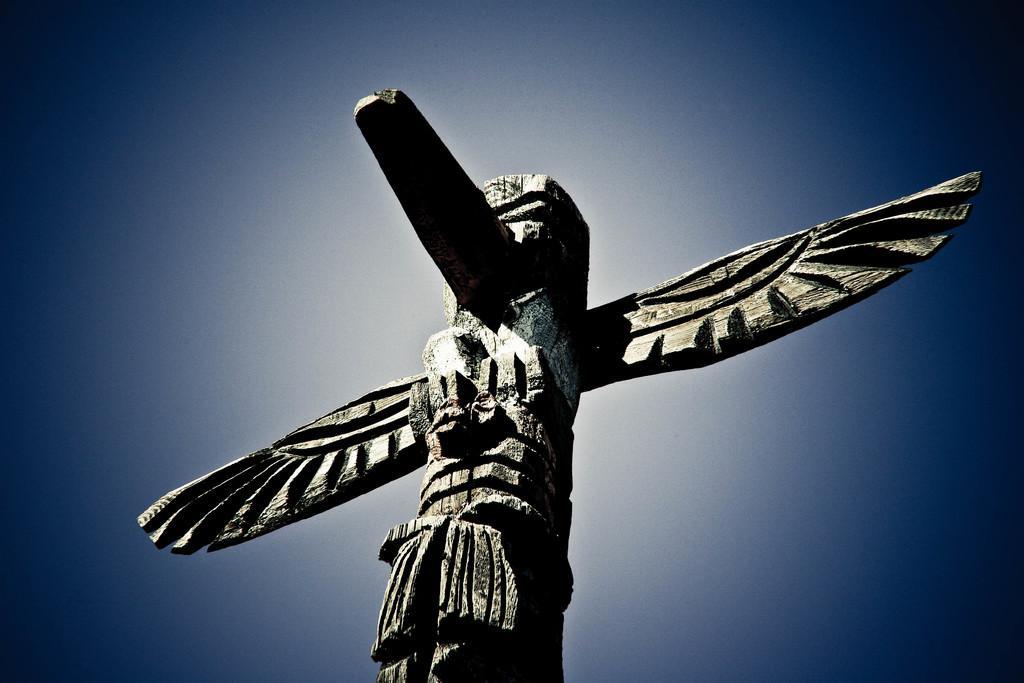How would you summarize this image in a sentence or two? This looks like a carving sculpture. The background looks blue and white in color. 